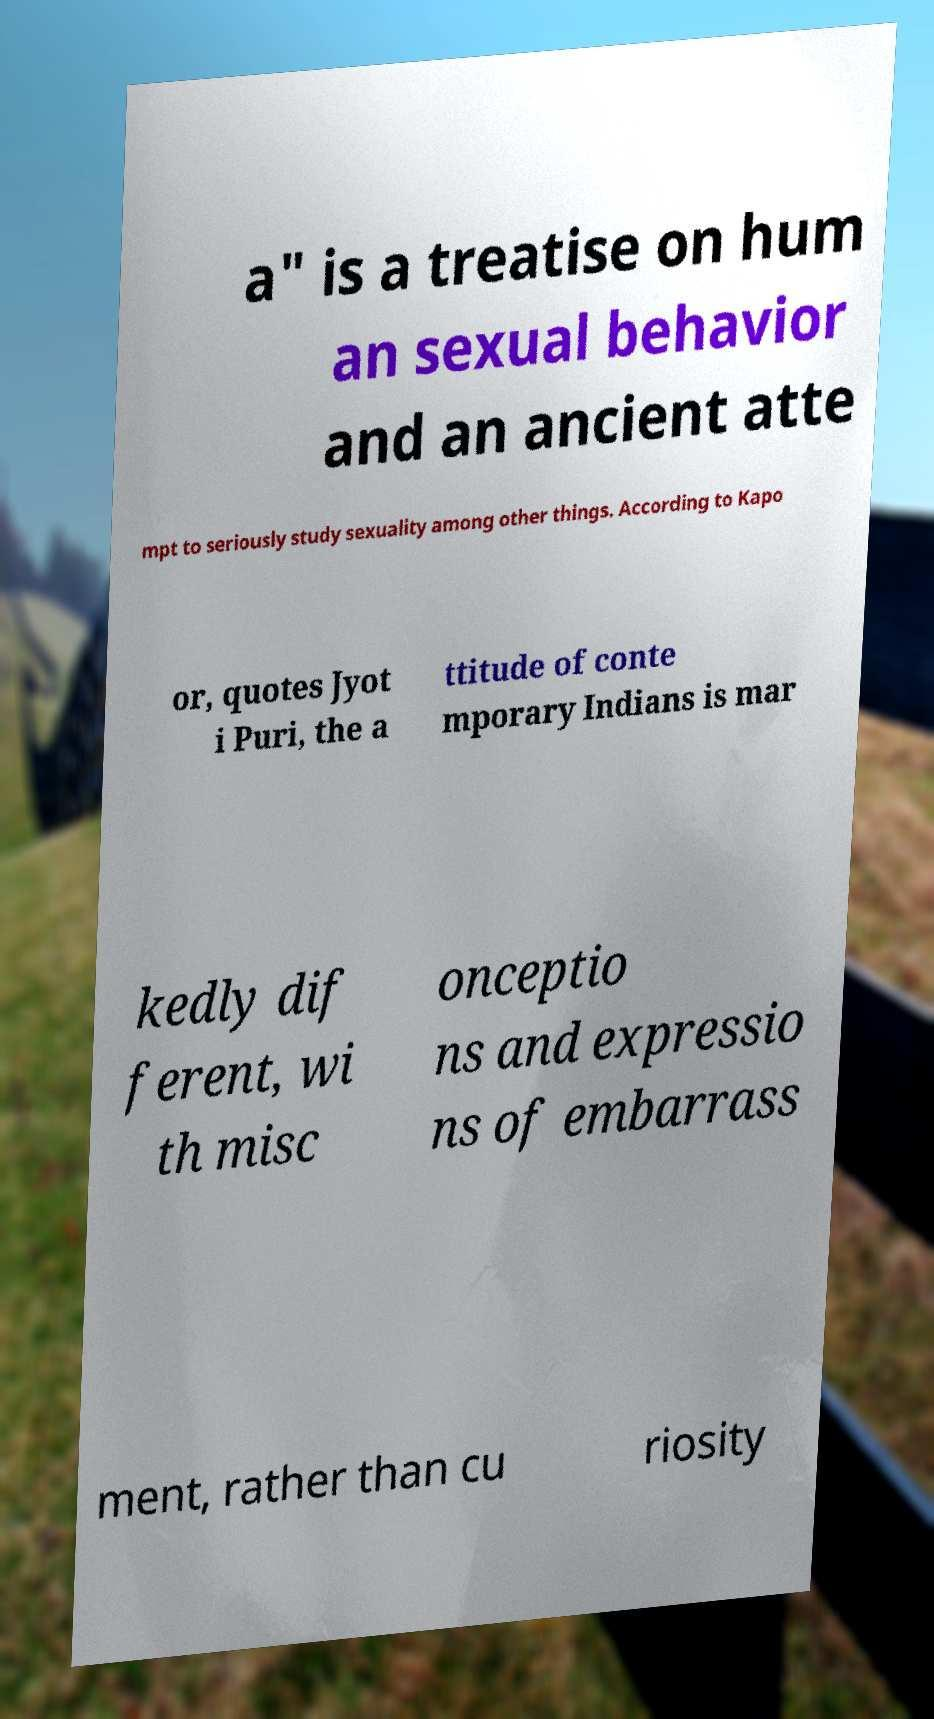Please identify and transcribe the text found in this image. a" is a treatise on hum an sexual behavior and an ancient atte mpt to seriously study sexuality among other things. According to Kapo or, quotes Jyot i Puri, the a ttitude of conte mporary Indians is mar kedly dif ferent, wi th misc onceptio ns and expressio ns of embarrass ment, rather than cu riosity 